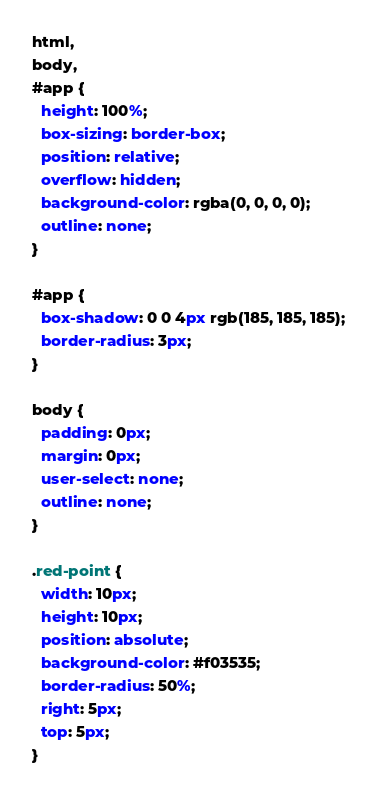Convert code to text. <code><loc_0><loc_0><loc_500><loc_500><_CSS_>html,
body,
#app {
  height: 100%;
  box-sizing: border-box;
  position: relative;
  overflow: hidden;
  background-color: rgba(0, 0, 0, 0);
  outline: none;
}

#app {
  box-shadow: 0 0 4px rgb(185, 185, 185);
  border-radius: 3px;
}

body {
  padding: 0px;
  margin: 0px;
  user-select: none;
  outline: none;
}

.red-point {
  width: 10px;
  height: 10px;
  position: absolute;
  background-color: #f03535;
  border-radius: 50%;
  right: 5px;
  top: 5px;
}</code> 